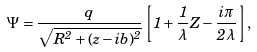Convert formula to latex. <formula><loc_0><loc_0><loc_500><loc_500>\Psi = \frac { q } { \sqrt { R ^ { 2 } + ( z - i b ) ^ { 2 } } } \left [ 1 + \frac { 1 } { \lambda } Z - \frac { i \pi } { 2 \lambda } \right ] ,</formula> 